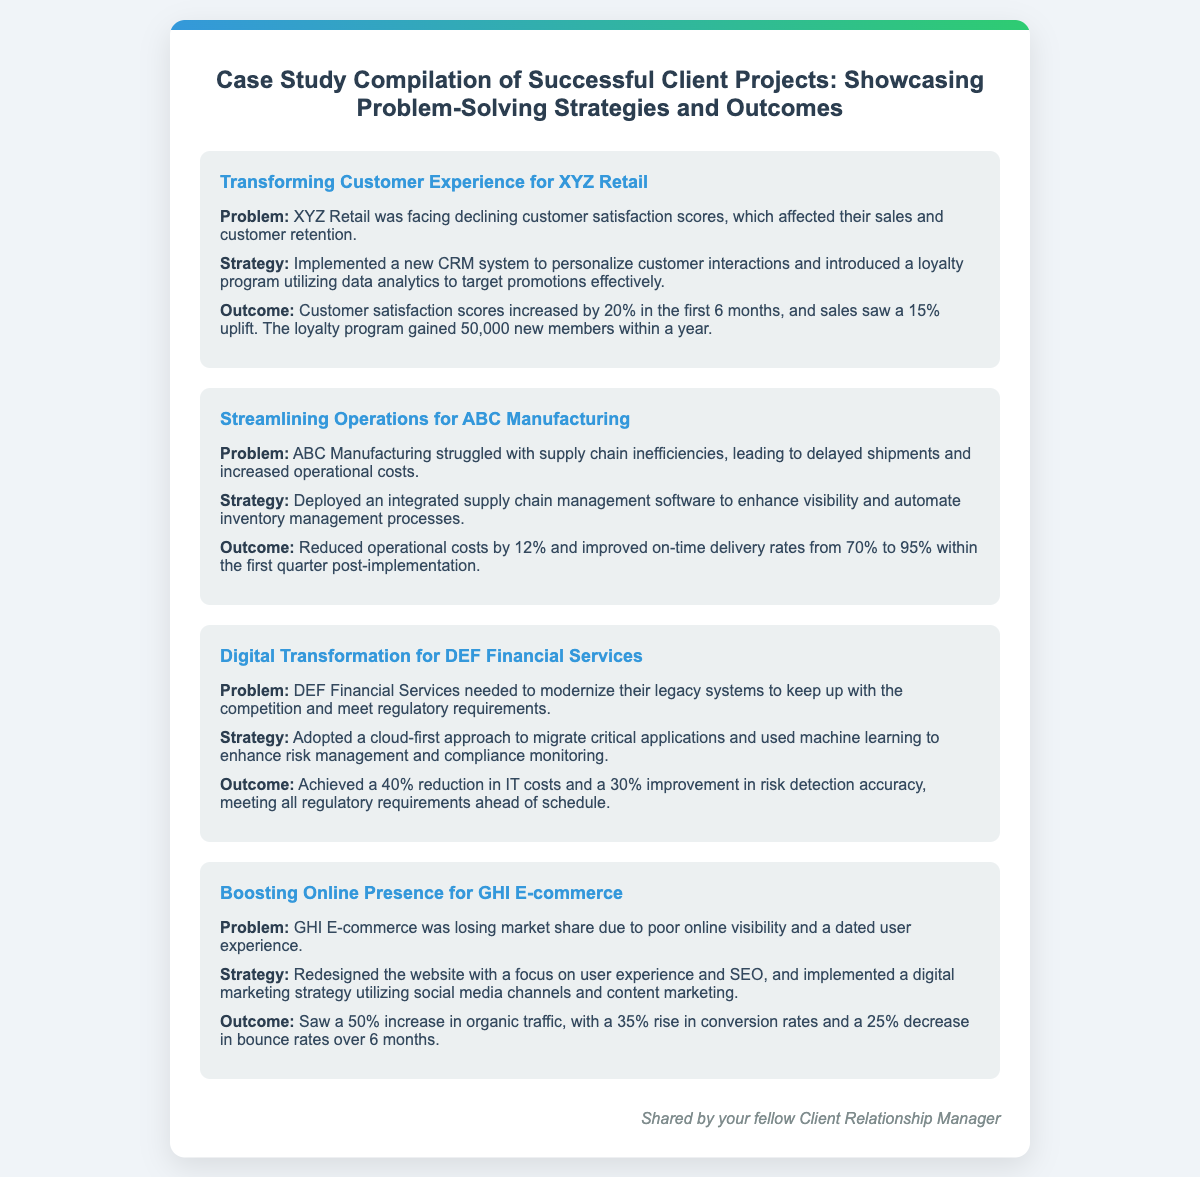What was the problem faced by XYZ Retail? The document states that XYZ Retail was facing declining customer satisfaction scores, which affected their sales and customer retention.
Answer: Declining customer satisfaction scores What strategy was implemented for ABC Manufacturing? The strategy mentioned for ABC Manufacturing was the deployment of integrated supply chain management software to enhance visibility and automate inventory management processes.
Answer: Integrated supply chain management software What was the outcome for DEF Financial Services? The outcome stated in the case study for DEF Financial Services was a 40% reduction in IT costs and a 30% improvement in risk detection accuracy.
Answer: 40% reduction in IT costs How many new members did the loyalty program gain for XYZ Retail? The document mentions that the loyalty program gained 50,000 new members within a year.
Answer: 50,000 new members What was the increase in organic traffic for GHI E-commerce? According to the case study, GHI E-commerce saw a 50% increase in organic traffic.
Answer: 50% increase What was the on-time delivery rate improvement for ABC Manufacturing? The improvement in on-time delivery rates reported for ABC Manufacturing was from 70% to 95% within the first quarter post-implementation.
Answer: 95% What approach was adopted by DEF Financial Services? DEF Financial Services adopted a cloud-first approach to migrate critical applications.
Answer: Cloud-first approach How much did customer satisfaction scores increase for XYZ Retail? Customer satisfaction scores increased by 20% in the first 6 months according to the document.
Answer: 20% What type of relationship management system was implemented for XYZ Retail? The implemented system for XYZ Retail was a new CRM system to personalize customer interactions.
Answer: New CRM system 